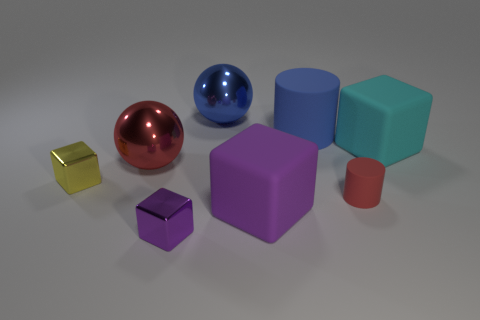What could be the possible use of these objects in a real-world setting? The objects seem to be simplistic geometric shapes, likely serving as educational or decorative items. They might be used to teach concepts like color, shape, volume, or material properties. Alternatively, they could be part of a designer's model or a child's playset. 